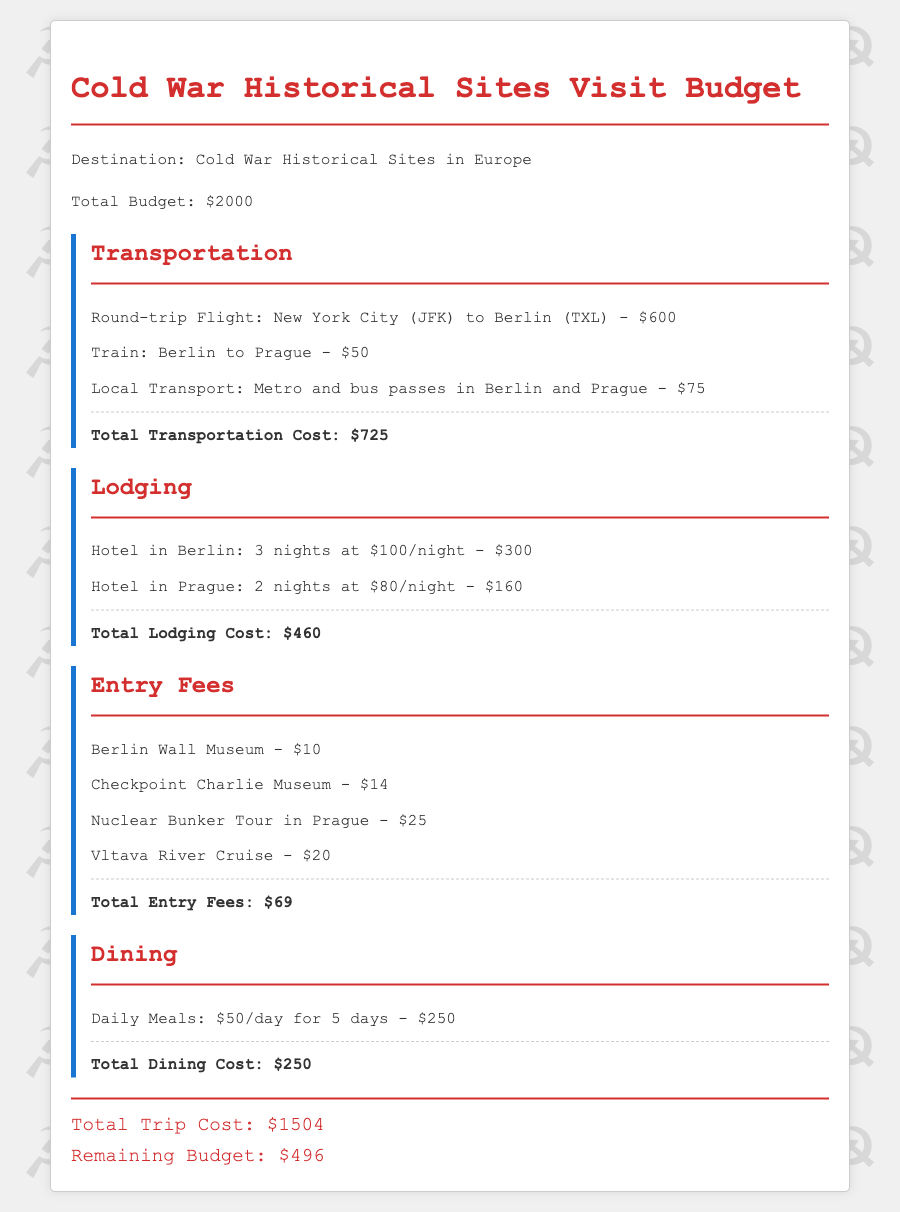What is the total budget for the trip? The total budget is stated directly in the document as $2000.
Answer: $2000 How much does the round-trip flight cost? The cost of the round-trip flight from New York City to Berlin is specifically listed as $600.
Answer: $600 What is the total cost for lodging? The total cost for lodging is the sum of hotel stays in Berlin and Prague, which is $460.
Answer: $460 What is the entry fee for the Berlin Wall Museum? The entry fee for the Berlin Wall Museum is mentioned as $10 in the document.
Answer: $10 How much money is remaining in the budget after total trip costs? The remaining budget is calculated as the total budget minus total trip costs, which is $496.
Answer: $496 What is the total cost of dining for the trip? The total cost for dining over 5 days is clearly stated as $250.
Answer: $250 How many nights will be spent in Prague? The document mentions that 2 nights will be spent in Prague, as detailed under lodging.
Answer: 2 nights What is the total entry fees for all listed activities? The document sums the entry fees for all activities, totaling $69.
Answer: $69 What type of transportation is included for local travel? Local transportation consists of metro and bus passes, as stated in the document.
Answer: Metro and bus passes 